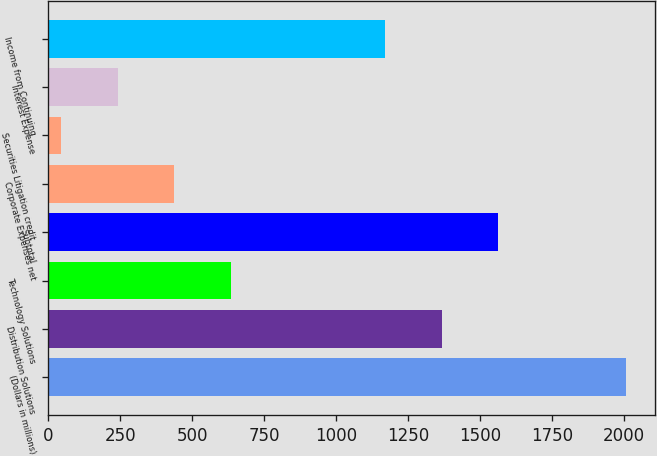<chart> <loc_0><loc_0><loc_500><loc_500><bar_chart><fcel>(Dollars in millions)<fcel>Distribution Solutions<fcel>Technology Solutions<fcel>Subtotal<fcel>Corporate Expenses net<fcel>Securities Litigation credit<fcel>Interest Expense<fcel>Income from Continuing<nl><fcel>2006<fcel>1367.1<fcel>633.3<fcel>1563.2<fcel>437.2<fcel>45<fcel>241.1<fcel>1171<nl></chart> 